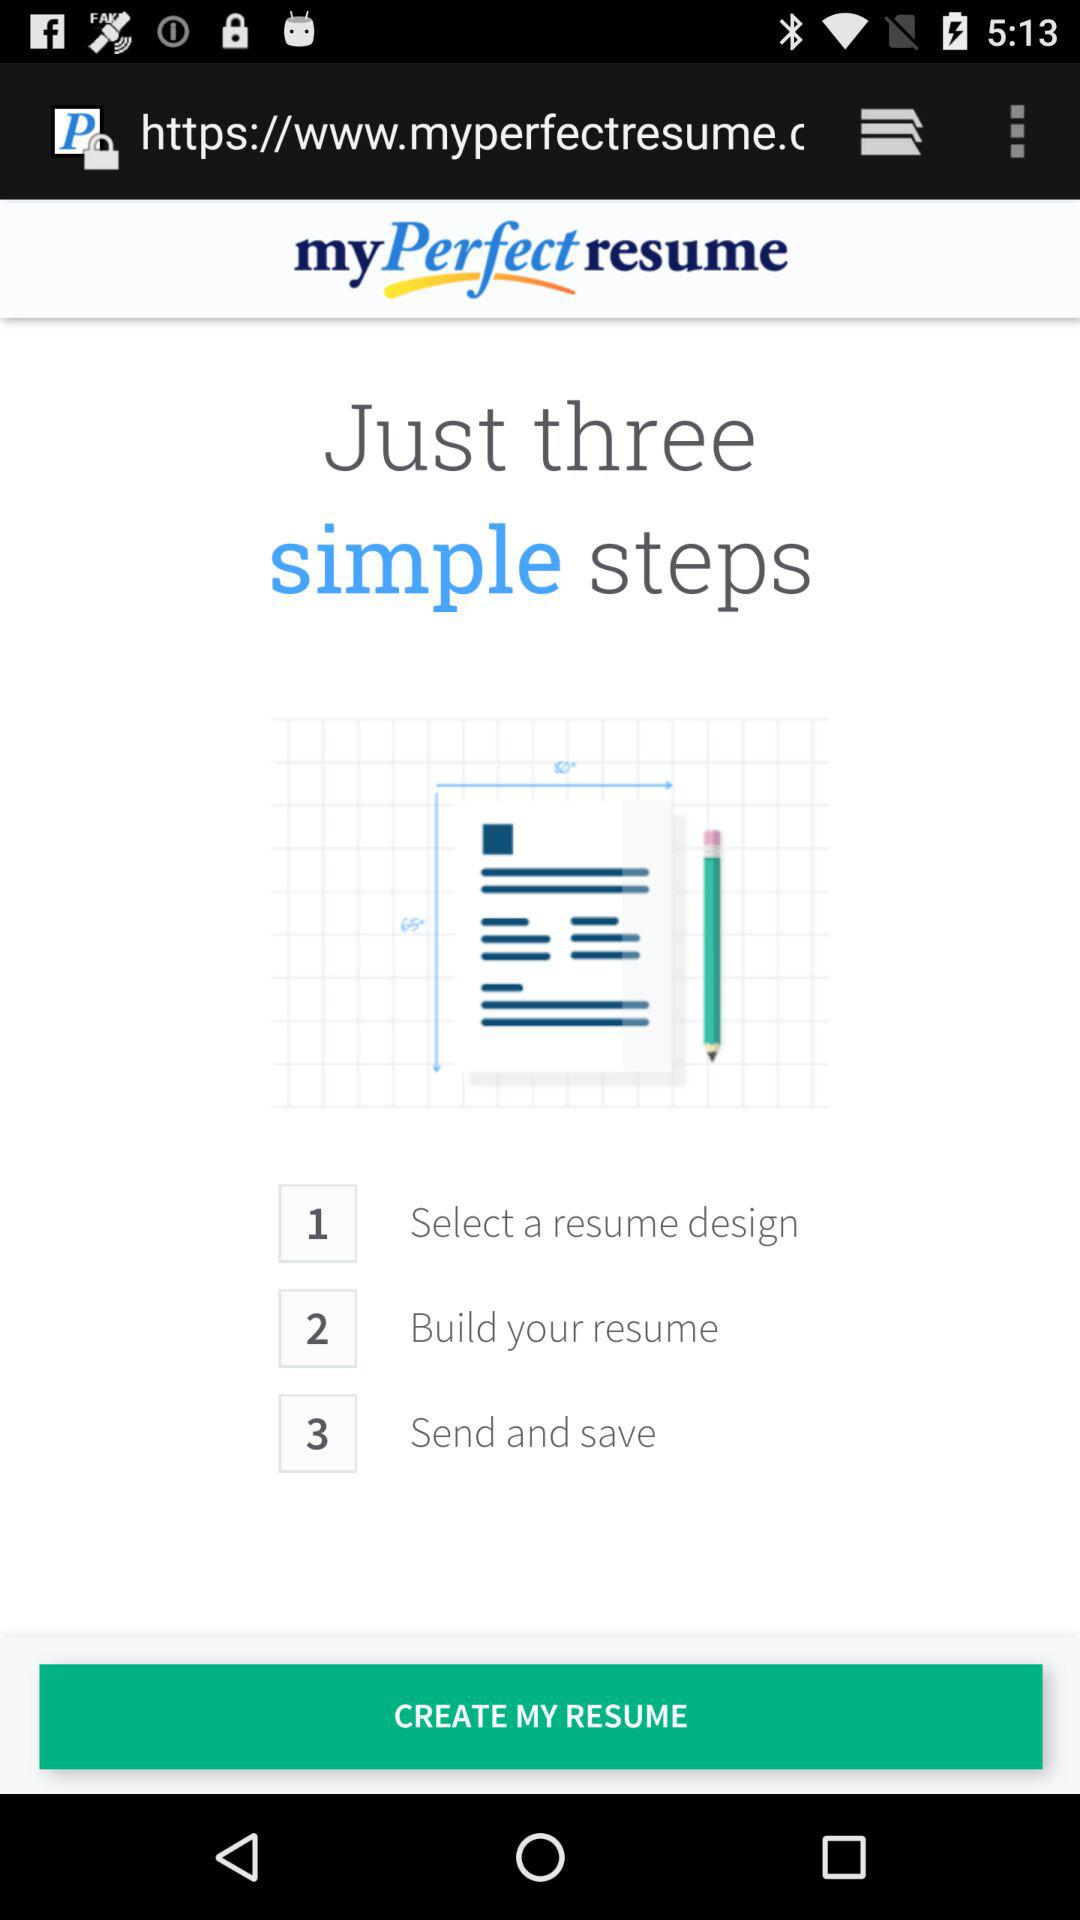What is the application name? The application name is "my Perfect resume". 